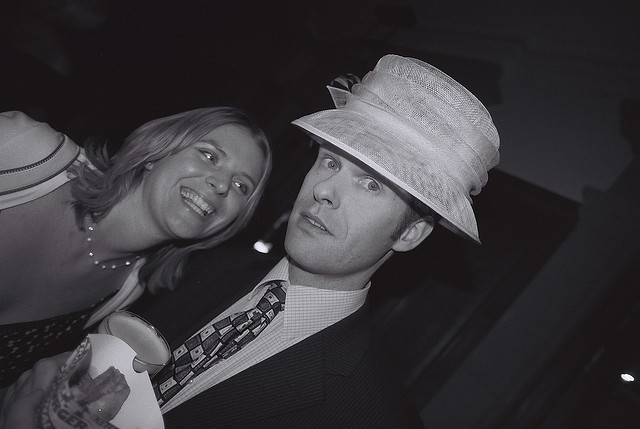What is the occasion? It appears to be a festive or special occasion, possibly a formal event given the attire of the subjects. Can you describe their expressions? The woman is smiling broadly, suggesting she is enjoying the moment. The man has a more neutral expression with a hint of a smirk, adding a sense of intrigue or playfulness to the scene. 